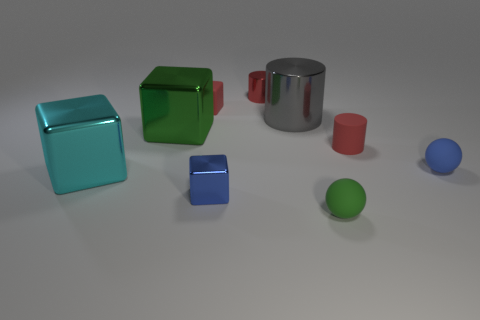What number of things are either shiny blocks that are to the left of the small metal cube or small red matte objects that are behind the tiny matte cylinder?
Provide a succinct answer. 3. What shape is the metallic object that is in front of the green metal object and left of the red matte block?
Make the answer very short. Cube. How many tiny rubber spheres are to the right of the red matte object that is to the right of the tiny metallic cylinder?
Give a very brief answer. 1. What number of objects are either small matte objects left of the green matte ball or tiny brown metallic things?
Make the answer very short. 1. What size is the green object behind the cyan thing?
Offer a terse response. Large. What is the material of the blue ball?
Keep it short and to the point. Rubber. What shape is the blue thing that is on the right side of the small red cylinder that is behind the gray metal cylinder?
Make the answer very short. Sphere. What number of other things are there of the same shape as the big gray metal object?
Give a very brief answer. 2. Are there any small red rubber blocks behind the red metallic cylinder?
Provide a succinct answer. No. What color is the tiny matte cylinder?
Your response must be concise. Red. 